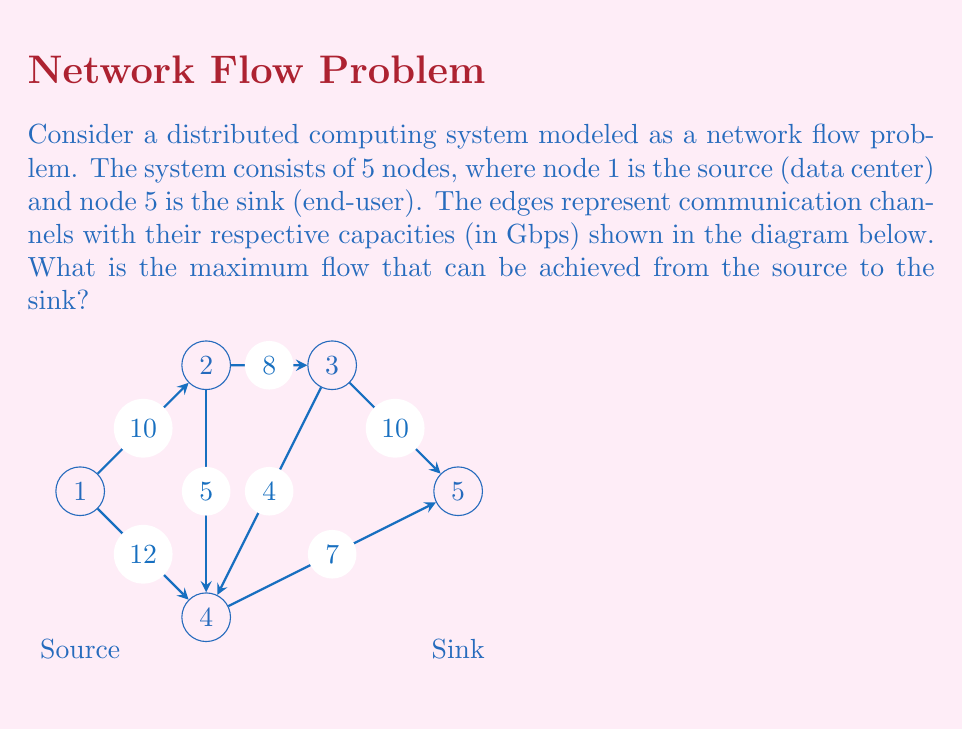Could you help me with this problem? To solve this problem, we'll use the Ford-Fulkerson algorithm to find the maximum flow in the network. Here's a step-by-step explanation:

1) Initialize the flow to 0 for all edges.

2) Find an augmenting path from source (1) to sink (5) with available capacity:
   Path 1: 1 -> 2 -> 3 -> 5 (min capacity: 8 Gbps)
   Update flow: 8 Gbps

3) Find another augmenting path:
   Path 2: 1 -> 4 -> 5 (min capacity: 7 Gbps)
   Update flow: 8 + 7 = 15 Gbps

4) Find another augmenting path:
   Path 3: 1 -> 2 -> 4 -> 5 (min capacity: 2 Gbps)
   Update flow: 15 + 2 = 17 Gbps

5) No more augmenting paths available.

The residual graph after these steps:
- Edge (1,2): 0 Gbps remaining
- Edge (1,4): 3 Gbps remaining
- Edge (2,3): 0 Gbps remaining
- Edge (2,4): 3 Gbps remaining
- Edge (3,5): 2 Gbps remaining
- Edge (4,5): 0 Gbps remaining

Therefore, the maximum flow from source to sink is 17 Gbps.

To verify, we can check the flow conservation at each node:
Node 1 (source): 10 + 7 = 17 Gbps out
Node 2: 10 in, 8 + 2 = 10 out
Node 3: 8 in, 8 out
Node 4: 7 + 2 = 9 in, 9 out
Node 5 (sink): 8 + 9 = 17 Gbps in

The flow is conserved at all nodes, confirming our result.
Answer: 17 Gbps 